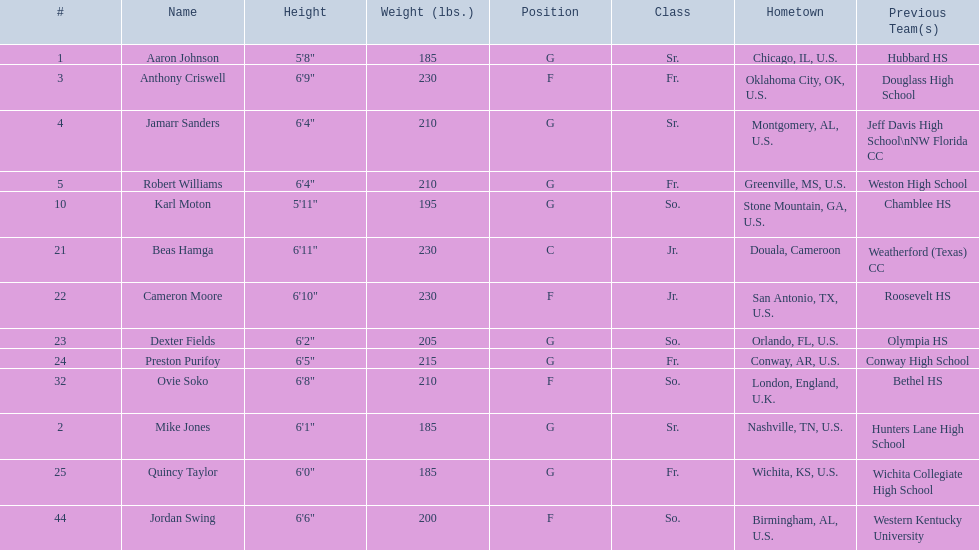Can you give me this table in json format? {'header': ['#', 'Name', 'Height', 'Weight (lbs.)', 'Position', 'Class', 'Hometown', 'Previous Team(s)'], 'rows': [['1', 'Aaron Johnson', '5\'8"', '185', 'G', 'Sr.', 'Chicago, IL, U.S.', 'Hubbard HS'], ['3', 'Anthony Criswell', '6\'9"', '230', 'F', 'Fr.', 'Oklahoma City, OK, U.S.', 'Douglass High School'], ['4', 'Jamarr Sanders', '6\'4"', '210', 'G', 'Sr.', 'Montgomery, AL, U.S.', 'Jeff Davis High School\\nNW Florida CC'], ['5', 'Robert Williams', '6\'4"', '210', 'G', 'Fr.', 'Greenville, MS, U.S.', 'Weston High School'], ['10', 'Karl Moton', '5\'11"', '195', 'G', 'So.', 'Stone Mountain, GA, U.S.', 'Chamblee HS'], ['21', 'Beas Hamga', '6\'11"', '230', 'C', 'Jr.', 'Douala, Cameroon', 'Weatherford (Texas) CC'], ['22', 'Cameron Moore', '6\'10"', '230', 'F', 'Jr.', 'San Antonio, TX, U.S.', 'Roosevelt HS'], ['23', 'Dexter Fields', '6\'2"', '205', 'G', 'So.', 'Orlando, FL, U.S.', 'Olympia HS'], ['24', 'Preston Purifoy', '6\'5"', '215', 'G', 'Fr.', 'Conway, AR, U.S.', 'Conway High School'], ['32', 'Ovie Soko', '6\'8"', '210', 'F', 'So.', 'London, England, U.K.', 'Bethel HS'], ['2', 'Mike Jones', '6\'1"', '185', 'G', 'Sr.', 'Nashville, TN, U.S.', 'Hunters Lane High School'], ['25', 'Quincy Taylor', '6\'0"', '185', 'G', 'Fr.', 'Wichita, KS, U.S.', 'Wichita Collegiate High School'], ['44', 'Jordan Swing', '6\'6"', '200', 'F', 'So.', 'Birmingham, AL, U.S.', 'Western Kentucky University']]} Who are all the players? Aaron Johnson, Anthony Criswell, Jamarr Sanders, Robert Williams, Karl Moton, Beas Hamga, Cameron Moore, Dexter Fields, Preston Purifoy, Ovie Soko, Mike Jones, Quincy Taylor, Jordan Swing. Of these, which are not soko? Aaron Johnson, Anthony Criswell, Jamarr Sanders, Robert Williams, Karl Moton, Beas Hamga, Cameron Moore, Dexter Fields, Preston Purifoy, Mike Jones, Quincy Taylor, Jordan Swing. Where are these players from? Sr., Fr., Sr., Fr., So., Jr., Jr., So., Fr., Sr., Fr., So. Of these locations, which are not in the u.s.? Jr. Which player is from this location? Beas Hamga. 